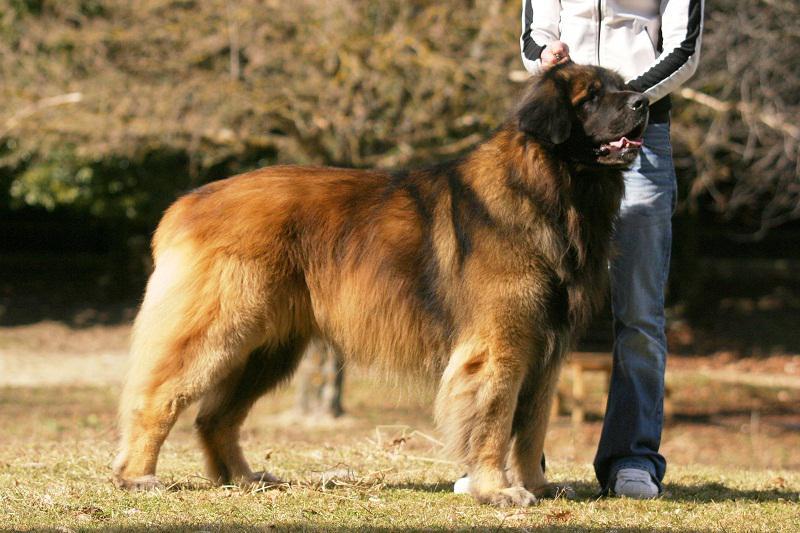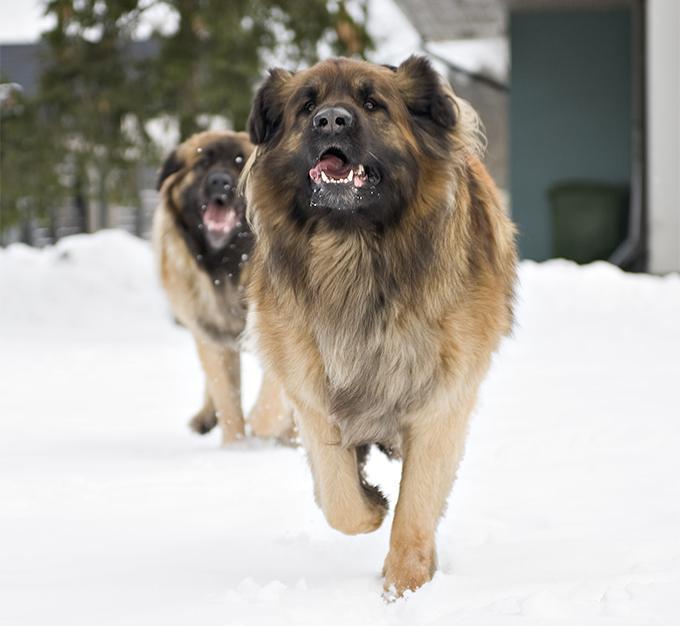The first image is the image on the left, the second image is the image on the right. Analyze the images presented: Is the assertion "A human is standing next to a large dog." valid? Answer yes or no. Yes. The first image is the image on the left, the second image is the image on the right. Considering the images on both sides, is "there is a human standing with a dog." valid? Answer yes or no. Yes. The first image is the image on the left, the second image is the image on the right. Considering the images on both sides, is "There are people touching or petting a big dog with a black nose." valid? Answer yes or no. Yes. The first image is the image on the left, the second image is the image on the right. For the images displayed, is the sentence "Dog sits with humans on a couch." factually correct? Answer yes or no. No. 